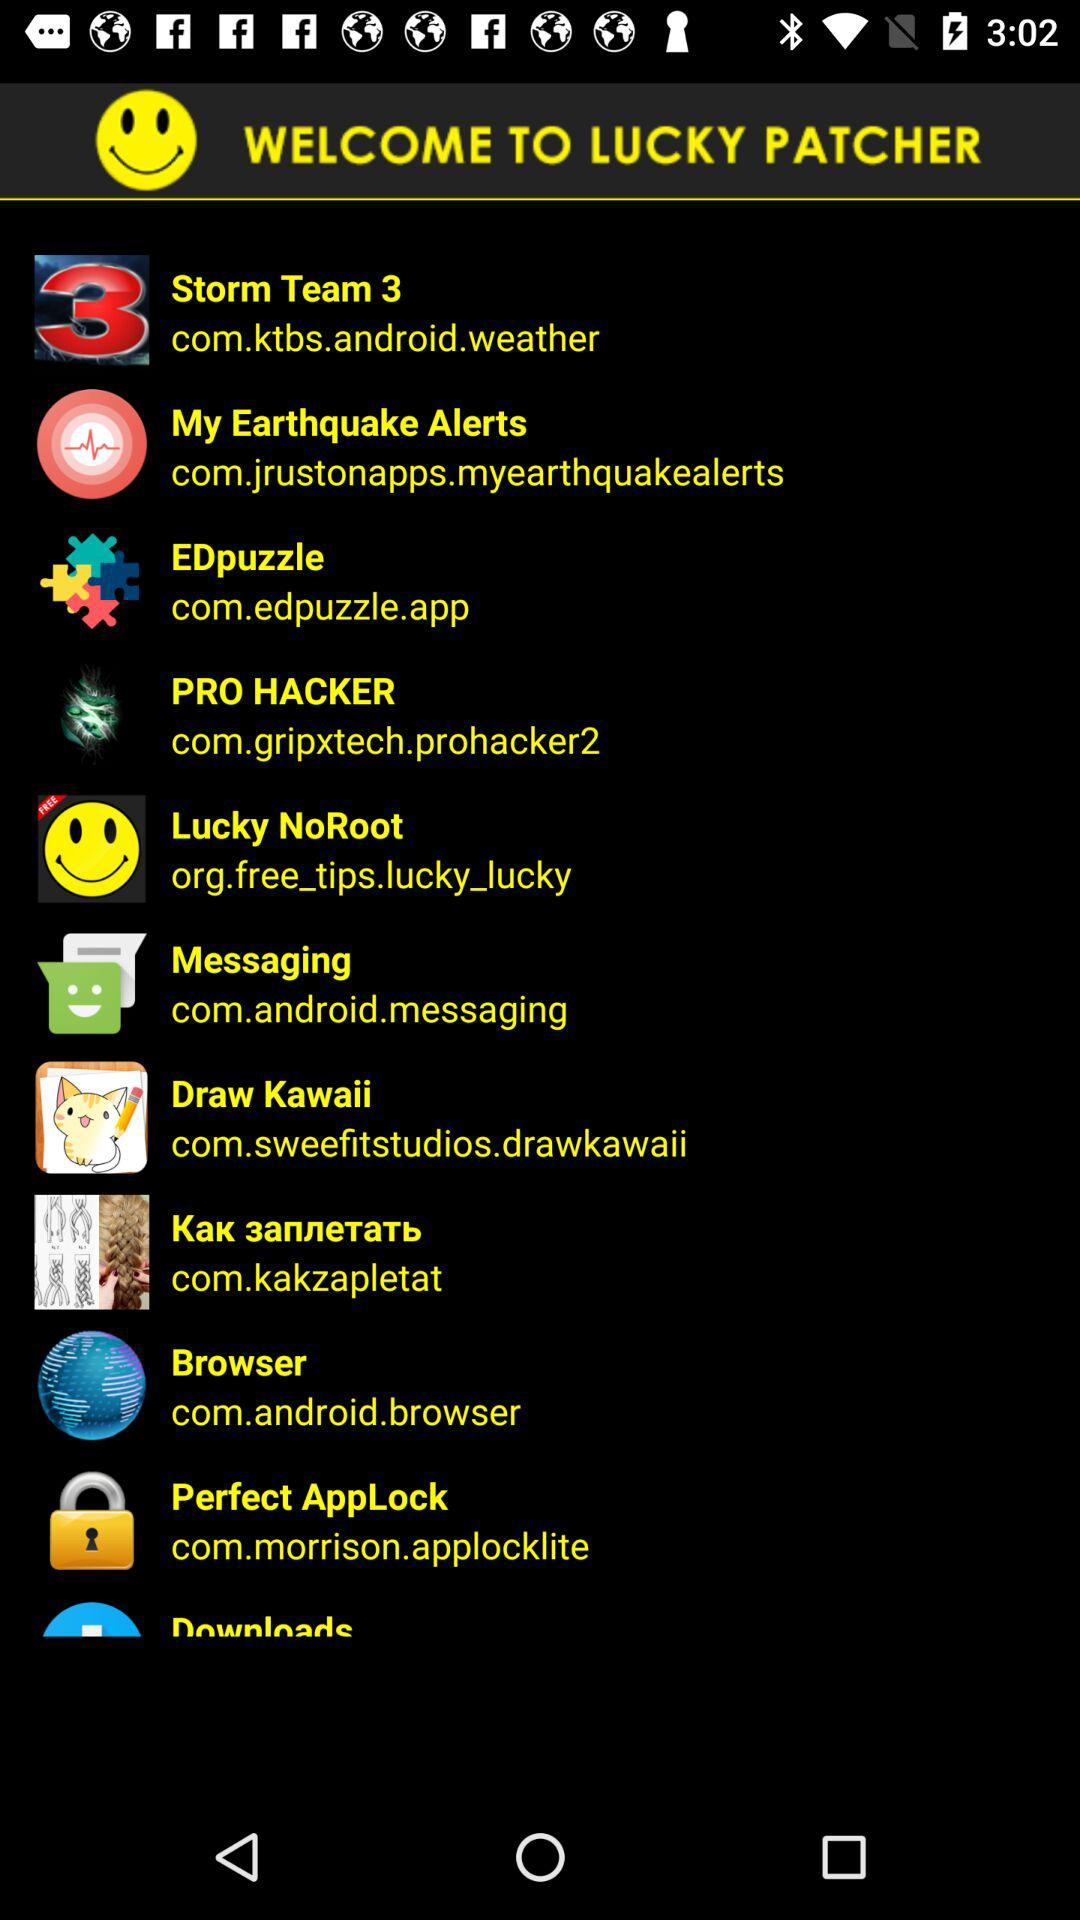What is the web site for PRO HACKER patching?
When the provided information is insufficient, respond with <no answer>. <no answer> 